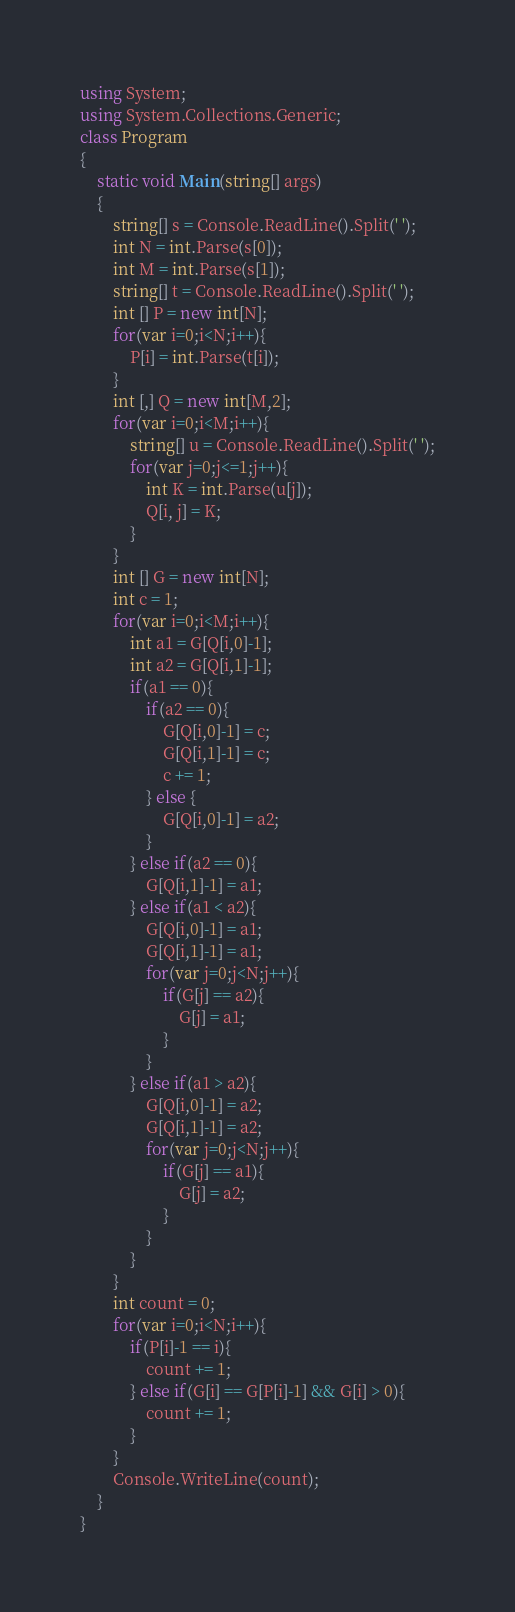<code> <loc_0><loc_0><loc_500><loc_500><_C#_>using System;
using System.Collections.Generic;
class Program
{
	static void Main(string[] args)
	{
		string[] s = Console.ReadLine().Split(' ');
		int N = int.Parse(s[0]);
		int M = int.Parse(s[1]);
		string[] t = Console.ReadLine().Split(' ');
		int [] P = new int[N];
		for(var i=0;i<N;i++){
			P[i] = int.Parse(t[i]);
		}
		int [,] Q = new int[M,2];
		for(var i=0;i<M;i++){
			string[] u = Console.ReadLine().Split(' ');
			for(var j=0;j<=1;j++){
				int K = int.Parse(u[j]);
				Q[i, j] = K;
			}
		}
		int [] G = new int[N];
		int c = 1;
		for(var i=0;i<M;i++){
			int a1 = G[Q[i,0]-1];
			int a2 = G[Q[i,1]-1];
			if(a1 == 0){
				if(a2 == 0){
					G[Q[i,0]-1] = c;
					G[Q[i,1]-1] = c;
					c += 1;
				} else {
					G[Q[i,0]-1] = a2;
				}
			} else if(a2 == 0){
				G[Q[i,1]-1] = a1;
			} else if(a1 < a2){
				G[Q[i,0]-1] = a1;
				G[Q[i,1]-1] = a1;
				for(var j=0;j<N;j++){
					if(G[j] == a2){
						G[j] = a1;
					}
				}
			} else if(a1 > a2){
				G[Q[i,0]-1] = a2;
				G[Q[i,1]-1] = a2;
				for(var j=0;j<N;j++){
					if(G[j] == a1){
						G[j] = a2;
					}
				}
			}
		}
		int count = 0;
		for(var i=0;i<N;i++){
			if(P[i]-1 == i){
				count += 1;
			} else if(G[i] == G[P[i]-1] && G[i] > 0){
				count += 1;
			}
		}
		Console.WriteLine(count);
	}
}</code> 